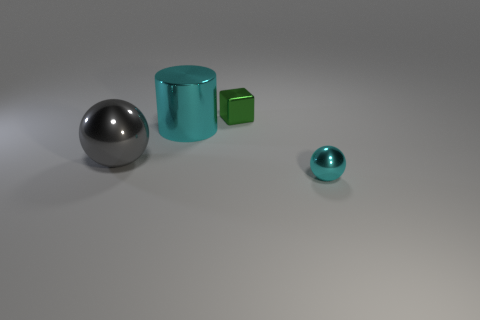Add 4 large objects. How many objects exist? 8 Subtract all cylinders. How many objects are left? 3 Subtract all large cyan shiny cylinders. Subtract all tiny green cubes. How many objects are left? 2 Add 2 big metal cylinders. How many big metal cylinders are left? 3 Add 1 shiny things. How many shiny things exist? 5 Subtract 0 green spheres. How many objects are left? 4 